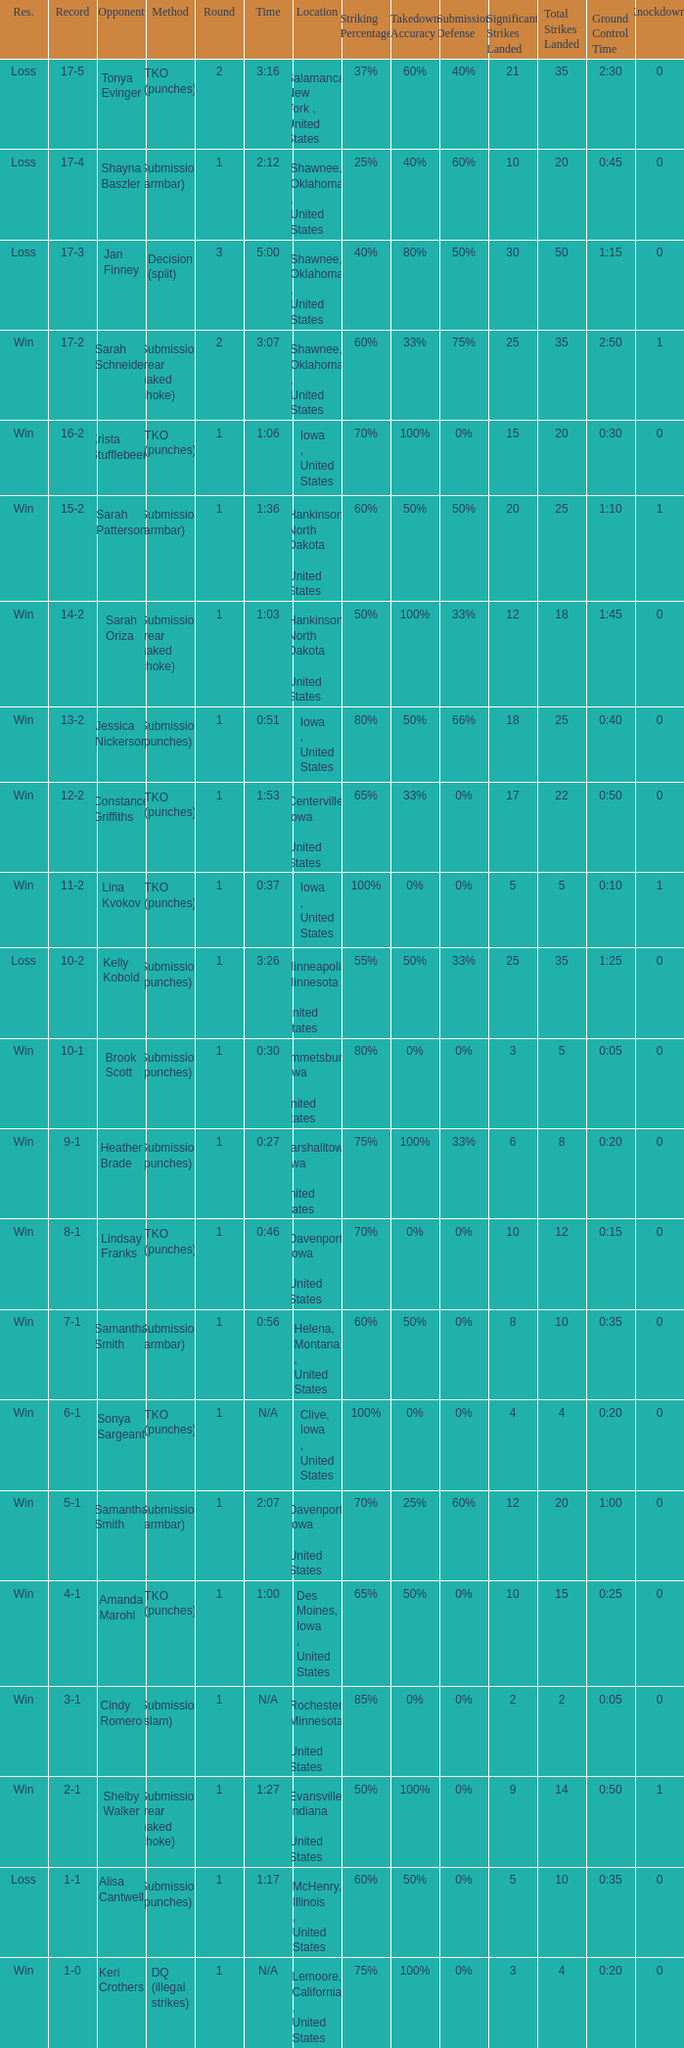What is the highest number of rounds for a 3:16 fight? 2.0. Can you give me this table as a dict? {'header': ['Res.', 'Record', 'Opponent', 'Method', 'Round', 'Time', 'Location', 'Striking Percentage', 'Takedown Accuracy', 'Submission Defense', 'Significant Strikes Landed', 'Total Strikes Landed', 'Ground Control Time', 'Knockdowns'], 'rows': [['Loss', '17-5', 'Tonya Evinger', 'TKO (punches)', '2', '3:16', 'Salamanca, New York , United States', '37%', '60%', '40%', '21', '35', '2:30', '0'], ['Loss', '17-4', 'Shayna Baszler', 'Submission (armbar)', '1', '2:12', 'Shawnee, Oklahoma , United States', '25%', '40%', '60%', '10', '20', '0:45', '0'], ['Loss', '17-3', 'Jan Finney', 'Decision (split)', '3', '5:00', 'Shawnee, Oklahoma , United States', '40%', '80%', '50%', '30', '50', '1:15', '0'], ['Win', '17-2', 'Sarah Schneider', 'Submission (rear naked choke)', '2', '3:07', 'Shawnee, Oklahoma , United States', '60%', '33%', '75%', '25', '35', '2:50', '1'], ['Win', '16-2', 'Krista Stufflebeem', 'TKO (punches)', '1', '1:06', 'Iowa , United States', '70%', '100%', '0%', '15', '20', '0:30', '0'], ['Win', '15-2', 'Sarah Patterson', 'Submission (armbar)', '1', '1:36', 'Hankinson, North Dakota , United States', '60%', '50%', '50%', '20', '25', '1:10', '1'], ['Win', '14-2', 'Sarah Oriza', 'Submission (rear naked choke)', '1', '1:03', 'Hankinson, North Dakota , United States', '50%', '100%', '33%', '12', '18', '1:45', '0'], ['Win', '13-2', 'Jessica Nickerson', 'Submission (punches)', '1', '0:51', 'Iowa , United States', '80%', '50%', '66%', '18', '25', '0:40', '0'], ['Win', '12-2', 'Constance Griffiths', 'TKO (punches)', '1', '1:53', 'Centerville, Iowa , United States', '65%', '33%', '0%', '17', '22', '0:50', '0'], ['Win', '11-2', 'Lina Kvokov', 'TKO (punches)', '1', '0:37', 'Iowa , United States', '100%', '0%', '0%', '5', '5', '0:10', '1'], ['Loss', '10-2', 'Kelly Kobold', 'Submission (punches)', '1', '3:26', 'Minneapolis, Minnesota , United States', '55%', '50%', '33%', '25', '35', '1:25', '0'], ['Win', '10-1', 'Brook Scott', 'Submission (punches)', '1', '0:30', 'Emmetsburg, Iowa , United States', '80%', '0%', '0%', '3', '5', '0:05', '0'], ['Win', '9-1', 'Heather Brade', 'Submission (punches)', '1', '0:27', 'Marshalltown, Iowa , United States', '75%', '100%', '33%', '6', '8', '0:20', '0'], ['Win', '8-1', 'Lindsay Franks', 'TKO (punches)', '1', '0:46', 'Davenport, Iowa , United States', '70%', '0%', '0%', '10', '12', '0:15', '0'], ['Win', '7-1', 'Samantha Smith', 'Submission (armbar)', '1', '0:56', 'Helena, Montana , United States', '60%', '50%', '0%', '8', '10', '0:35', '0'], ['Win', '6-1', 'Sonya Sargeant', 'TKO (punches)', '1', 'N/A', 'Clive, Iowa , United States', '100%', '0%', '0%', '4', '4', '0:20', '0'], ['Win', '5-1', 'Samantha Smith', 'Submission (armbar)', '1', '2:07', 'Davenport, Iowa , United States', '70%', '25%', '60%', '12', '20', '1:00', '0'], ['Win', '4-1', 'Amanda Marohl', 'TKO (punches)', '1', '1:00', 'Des Moines, Iowa , United States', '65%', '50%', '0%', '10', '15', '0:25', '0'], ['Win', '3-1', 'Cindy Romero', 'Submission (slam)', '1', 'N/A', 'Rochester, Minnesota , United States', '85%', '0%', '0%', '2', '2', '0:05', '0'], ['Win', '2-1', 'Shelby Walker', 'Submission (rear naked choke)', '1', '1:27', 'Evansville, Indiana , United States', '50%', '100%', '0%', '9', '14', '0:50', '1'], ['Loss', '1-1', 'Alisa Cantwell', 'Submission (punches)', '1', '1:17', 'McHenry, Illinois , United States', '60%', '50%', '0%', '5', '10', '0:35', '0'], ['Win', '1-0', 'Keri Crothers', 'DQ (illegal strikes)', '1', 'N/A', 'Lemoore, California , United States', '75%', '100%', '0%', '3', '4', '0:20', '0']]} 